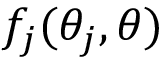Convert formula to latex. <formula><loc_0><loc_0><loc_500><loc_500>f _ { j } ( \theta _ { j } , \theta )</formula> 